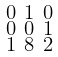Convert formula to latex. <formula><loc_0><loc_0><loc_500><loc_500>\begin{smallmatrix} 0 & 1 & 0 \\ 0 & 0 & 1 \\ 1 & 8 & 2 \end{smallmatrix}</formula> 